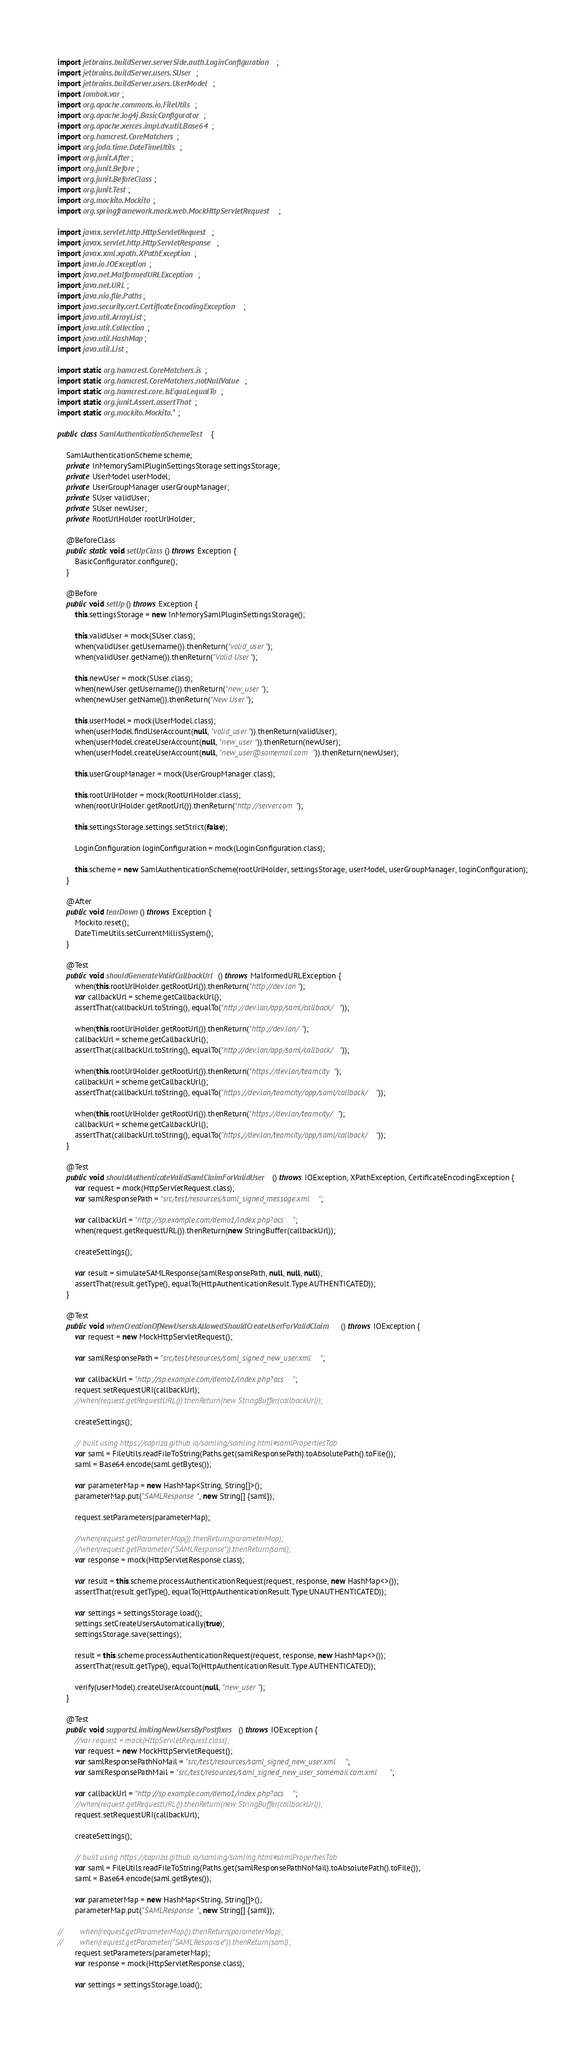<code> <loc_0><loc_0><loc_500><loc_500><_Java_>import jetbrains.buildServer.serverSide.auth.LoginConfiguration;
import jetbrains.buildServer.users.SUser;
import jetbrains.buildServer.users.UserModel;
import lombok.var;
import org.apache.commons.io.FileUtils;
import org.apache.log4j.BasicConfigurator;
import org.apache.xerces.impl.dv.util.Base64;
import org.hamcrest.CoreMatchers;
import org.joda.time.DateTimeUtils;
import org.junit.After;
import org.junit.Before;
import org.junit.BeforeClass;
import org.junit.Test;
import org.mockito.Mockito;
import org.springframework.mock.web.MockHttpServletRequest;

import javax.servlet.http.HttpServletRequest;
import javax.servlet.http.HttpServletResponse;
import javax.xml.xpath.XPathException;
import java.io.IOException;
import java.net.MalformedURLException;
import java.net.URL;
import java.nio.file.Paths;
import java.security.cert.CertificateEncodingException;
import java.util.ArrayList;
import java.util.Collection;
import java.util.HashMap;
import java.util.List;

import static org.hamcrest.CoreMatchers.is;
import static org.hamcrest.CoreMatchers.notNullValue;
import static org.hamcrest.core.IsEqual.equalTo;
import static org.junit.Assert.assertThat;
import static org.mockito.Mockito.*;

public class SamlAuthenticationSchemeTest {

    SamlAuthenticationScheme scheme;
    private InMemorySamlPluginSettingsStorage settingsStorage;
    private UserModel userModel;
    private UserGroupManager userGroupManager;
    private SUser validUser;
    private SUser newUser;
    private RootUrlHolder rootUrlHolder;

    @BeforeClass
    public static void setUpClass() throws Exception {
        BasicConfigurator.configure();
    }

    @Before
    public void setUp() throws Exception {
        this.settingsStorage = new InMemorySamlPluginSettingsStorage();

        this.validUser = mock(SUser.class);
        when(validUser.getUsername()).thenReturn("valid_user");
        when(validUser.getName()).thenReturn("Valid User");

        this.newUser = mock(SUser.class);
        when(newUser.getUsername()).thenReturn("new_user");
        when(newUser.getName()).thenReturn("New User");

        this.userModel = mock(UserModel.class);
        when(userModel.findUserAccount(null, "valid_user")).thenReturn(validUser);
        when(userModel.createUserAccount(null, "new_user")).thenReturn(newUser);
        when(userModel.createUserAccount(null, "new_user@somemail.com")).thenReturn(newUser);

        this.userGroupManager = mock(UserGroupManager.class);

        this.rootUrlHolder = mock(RootUrlHolder.class);
        when(rootUrlHolder.getRootUrl()).thenReturn("http://server.com");

        this.settingsStorage.settings.setStrict(false);

        LoginConfiguration loginConfiguration = mock(LoginConfiguration.class);

        this.scheme = new SamlAuthenticationScheme(rootUrlHolder, settingsStorage, userModel, userGroupManager, loginConfiguration);
    }

    @After
    public void tearDown() throws Exception {
        Mockito.reset();
        DateTimeUtils.setCurrentMillisSystem();
    }

    @Test
    public void shouldGenerateValidCallbackUrl() throws MalformedURLException {
        when(this.rootUrlHolder.getRootUrl()).thenReturn("http://dev.lan");
        var callbackUrl = scheme.getCallbackUrl();
        assertThat(callbackUrl.toString(), equalTo("http://dev.lan/app/saml/callback/"));

        when(this.rootUrlHolder.getRootUrl()).thenReturn("http://dev.lan/");
        callbackUrl = scheme.getCallbackUrl();
        assertThat(callbackUrl.toString(), equalTo("http://dev.lan/app/saml/callback/"));

        when(this.rootUrlHolder.getRootUrl()).thenReturn("https://dev.lan/teamcity");
        callbackUrl = scheme.getCallbackUrl();
        assertThat(callbackUrl.toString(), equalTo("https://dev.lan/teamcity/app/saml/callback/"));

        when(this.rootUrlHolder.getRootUrl()).thenReturn("https://dev.lan/teamcity/");
        callbackUrl = scheme.getCallbackUrl();
        assertThat(callbackUrl.toString(), equalTo("https://dev.lan/teamcity/app/saml/callback/"));
    }

    @Test
    public void shouldAuthenticateValidSamlClaimForValidUser() throws IOException, XPathException, CertificateEncodingException {
        var request = mock(HttpServletRequest.class);
        var samlResponsePath = "src/test/resources/saml_signed_message.xml";

        var callbackUrl = "http://sp.example.com/demo1/index.php?acs";
        when(request.getRequestURL()).thenReturn(new StringBuffer(callbackUrl));

        createSettings();

        var result = simulateSAMLResponse(samlResponsePath, null, null, null);
        assertThat(result.getType(), equalTo(HttpAuthenticationResult.Type.AUTHENTICATED));
    }

    @Test
    public void whenCreationOfNewUsersIsAllowedShouldCreateUserForValidClaim() throws IOException {
        var request = new MockHttpServletRequest();

        var samlResponsePath = "src/test/resources/saml_signed_new_user.xml";

        var callbackUrl = "http://sp.example.com/demo1/index.php?acs";
        request.setRequestURI(callbackUrl);
        //when(request.getRequestURL()).thenReturn(new StringBuffer(callbackUrl));

        createSettings();

        // built using https://capriza.github.io/samling/samling.html#samlPropertiesTab
        var saml = FileUtils.readFileToString(Paths.get(samlResponsePath).toAbsolutePath().toFile());
        saml = Base64.encode(saml.getBytes());

        var parameterMap = new HashMap<String, String[]>();
        parameterMap.put("SAMLResponse", new String[] {saml});

        request.setParameters(parameterMap);

        //when(request.getParameterMap()).thenReturn(parameterMap);
        //when(request.getParameter("SAMLResponse")).thenReturn(saml);
        var response = mock(HttpServletResponse.class);

        var result = this.scheme.processAuthenticationRequest(request, response, new HashMap<>());
        assertThat(result.getType(), equalTo(HttpAuthenticationResult.Type.UNAUTHENTICATED));

        var settings = settingsStorage.load();
        settings.setCreateUsersAutomatically(true);
        settingsStorage.save(settings);

        result = this.scheme.processAuthenticationRequest(request, response, new HashMap<>());
        assertThat(result.getType(), equalTo(HttpAuthenticationResult.Type.AUTHENTICATED));

        verify(userModel).createUserAccount(null, "new_user");
    }

    @Test
    public void supportsLimitingNewUsersByPostfixes() throws IOException {
        //var request = mock(HttpServletRequest.class);
        var request = new MockHttpServletRequest();
        var samlResponsePathNoMail = "src/test/resources/saml_signed_new_user.xml";
        var samlResponsePathMail = "src/test/resources/saml_signed_new_user_somemail.com.xml";

        var callbackUrl = "http://sp.example.com/demo1/index.php?acs";
        //when(request.getRequestURL()).thenReturn(new StringBuffer(callbackUrl));
        request.setRequestURI(callbackUrl);

        createSettings();

        // built using https://capriza.github.io/samling/samling.html#samlPropertiesTab
        var saml = FileUtils.readFileToString(Paths.get(samlResponsePathNoMail).toAbsolutePath().toFile());
        saml = Base64.encode(saml.getBytes());

        var parameterMap = new HashMap<String, String[]>();
        parameterMap.put("SAMLResponse", new String[] {saml});

//        when(request.getParameterMap()).thenReturn(parameterMap);
//        when(request.getParameter("SAMLResponse")).thenReturn(saml);
        request.setParameters(parameterMap);
        var response = mock(HttpServletResponse.class);

        var settings = settingsStorage.load();</code> 